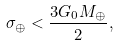Convert formula to latex. <formula><loc_0><loc_0><loc_500><loc_500>\sigma _ { \oplus } < \frac { 3 G _ { 0 } M _ { \oplus } } { 2 } ,</formula> 